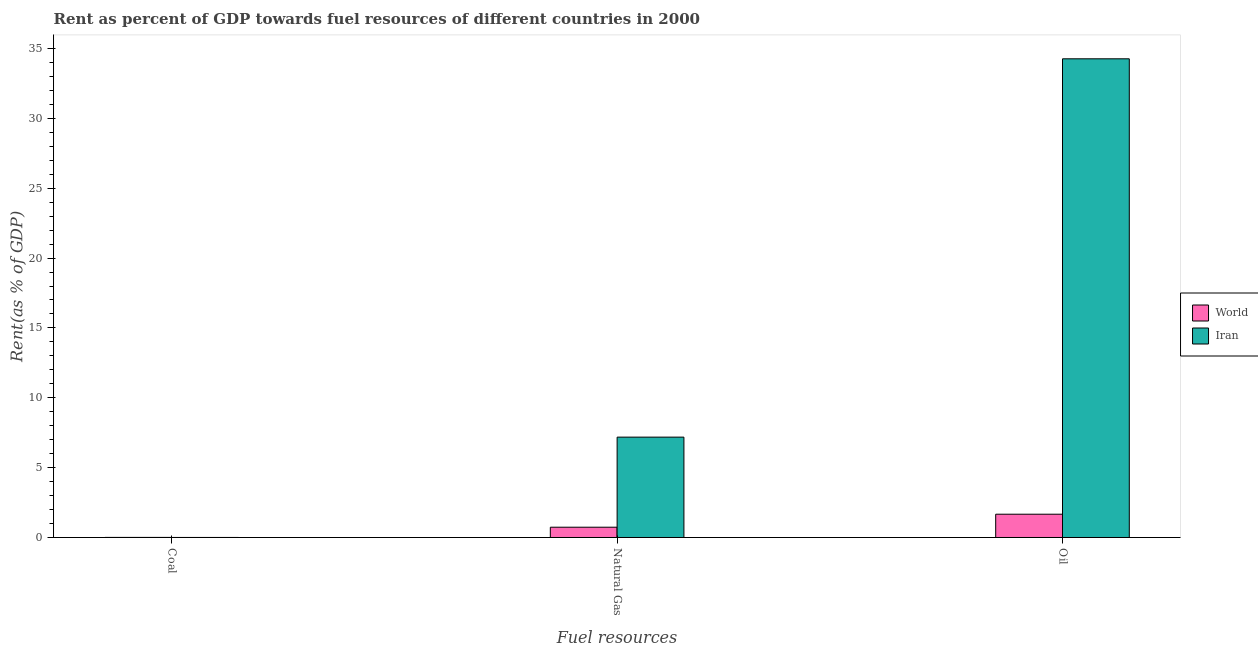Are the number of bars on each tick of the X-axis equal?
Offer a terse response. Yes. How many bars are there on the 2nd tick from the left?
Provide a short and direct response. 2. What is the label of the 1st group of bars from the left?
Provide a short and direct response. Coal. What is the rent towards oil in World?
Offer a terse response. 1.67. Across all countries, what is the maximum rent towards natural gas?
Offer a terse response. 7.18. Across all countries, what is the minimum rent towards oil?
Your answer should be compact. 1.67. In which country was the rent towards natural gas maximum?
Your answer should be very brief. Iran. What is the total rent towards coal in the graph?
Give a very brief answer. 0.01. What is the difference between the rent towards oil in World and that in Iran?
Provide a short and direct response. -32.6. What is the difference between the rent towards natural gas in World and the rent towards coal in Iran?
Keep it short and to the point. 0.73. What is the average rent towards coal per country?
Offer a very short reply. 0. What is the difference between the rent towards coal and rent towards oil in World?
Provide a short and direct response. -1.66. What is the ratio of the rent towards oil in Iran to that in World?
Provide a short and direct response. 20.56. Is the difference between the rent towards oil in Iran and World greater than the difference between the rent towards coal in Iran and World?
Give a very brief answer. Yes. What is the difference between the highest and the second highest rent towards natural gas?
Give a very brief answer. 6.45. What is the difference between the highest and the lowest rent towards coal?
Make the answer very short. 0. In how many countries, is the rent towards coal greater than the average rent towards coal taken over all countries?
Your answer should be very brief. 1. What does the 2nd bar from the left in Coal represents?
Make the answer very short. Iran. What does the 1st bar from the right in Coal represents?
Your response must be concise. Iran. How many bars are there?
Provide a short and direct response. 6. Are all the bars in the graph horizontal?
Provide a short and direct response. No. How many legend labels are there?
Your response must be concise. 2. How are the legend labels stacked?
Your answer should be compact. Vertical. What is the title of the graph?
Give a very brief answer. Rent as percent of GDP towards fuel resources of different countries in 2000. What is the label or title of the X-axis?
Provide a succinct answer. Fuel resources. What is the label or title of the Y-axis?
Give a very brief answer. Rent(as % of GDP). What is the Rent(as % of GDP) in World in Coal?
Make the answer very short. 0.01. What is the Rent(as % of GDP) of Iran in Coal?
Offer a terse response. 0. What is the Rent(as % of GDP) of World in Natural Gas?
Keep it short and to the point. 0.74. What is the Rent(as % of GDP) of Iran in Natural Gas?
Provide a short and direct response. 7.18. What is the Rent(as % of GDP) of World in Oil?
Provide a short and direct response. 1.67. What is the Rent(as % of GDP) in Iran in Oil?
Keep it short and to the point. 34.26. Across all Fuel resources, what is the maximum Rent(as % of GDP) of World?
Make the answer very short. 1.67. Across all Fuel resources, what is the maximum Rent(as % of GDP) in Iran?
Give a very brief answer. 34.26. Across all Fuel resources, what is the minimum Rent(as % of GDP) in World?
Provide a succinct answer. 0.01. Across all Fuel resources, what is the minimum Rent(as % of GDP) of Iran?
Your answer should be very brief. 0. What is the total Rent(as % of GDP) in World in the graph?
Your answer should be compact. 2.41. What is the total Rent(as % of GDP) of Iran in the graph?
Provide a short and direct response. 41.45. What is the difference between the Rent(as % of GDP) in World in Coal and that in Natural Gas?
Give a very brief answer. -0.73. What is the difference between the Rent(as % of GDP) of Iran in Coal and that in Natural Gas?
Offer a very short reply. -7.18. What is the difference between the Rent(as % of GDP) of World in Coal and that in Oil?
Offer a very short reply. -1.66. What is the difference between the Rent(as % of GDP) of Iran in Coal and that in Oil?
Make the answer very short. -34.26. What is the difference between the Rent(as % of GDP) of World in Natural Gas and that in Oil?
Your response must be concise. -0.93. What is the difference between the Rent(as % of GDP) of Iran in Natural Gas and that in Oil?
Offer a terse response. -27.08. What is the difference between the Rent(as % of GDP) of World in Coal and the Rent(as % of GDP) of Iran in Natural Gas?
Give a very brief answer. -7.18. What is the difference between the Rent(as % of GDP) of World in Coal and the Rent(as % of GDP) of Iran in Oil?
Offer a very short reply. -34.26. What is the difference between the Rent(as % of GDP) in World in Natural Gas and the Rent(as % of GDP) in Iran in Oil?
Your answer should be compact. -33.53. What is the average Rent(as % of GDP) in World per Fuel resources?
Ensure brevity in your answer.  0.8. What is the average Rent(as % of GDP) of Iran per Fuel resources?
Provide a short and direct response. 13.82. What is the difference between the Rent(as % of GDP) in World and Rent(as % of GDP) in Iran in Coal?
Provide a succinct answer. 0. What is the difference between the Rent(as % of GDP) in World and Rent(as % of GDP) in Iran in Natural Gas?
Make the answer very short. -6.45. What is the difference between the Rent(as % of GDP) in World and Rent(as % of GDP) in Iran in Oil?
Your answer should be very brief. -32.6. What is the ratio of the Rent(as % of GDP) in World in Coal to that in Natural Gas?
Offer a terse response. 0.01. What is the ratio of the Rent(as % of GDP) of Iran in Coal to that in Natural Gas?
Keep it short and to the point. 0. What is the ratio of the Rent(as % of GDP) in World in Coal to that in Oil?
Provide a succinct answer. 0. What is the ratio of the Rent(as % of GDP) in World in Natural Gas to that in Oil?
Make the answer very short. 0.44. What is the ratio of the Rent(as % of GDP) in Iran in Natural Gas to that in Oil?
Ensure brevity in your answer.  0.21. What is the difference between the highest and the second highest Rent(as % of GDP) in World?
Offer a very short reply. 0.93. What is the difference between the highest and the second highest Rent(as % of GDP) of Iran?
Your answer should be very brief. 27.08. What is the difference between the highest and the lowest Rent(as % of GDP) of World?
Your response must be concise. 1.66. What is the difference between the highest and the lowest Rent(as % of GDP) of Iran?
Provide a short and direct response. 34.26. 